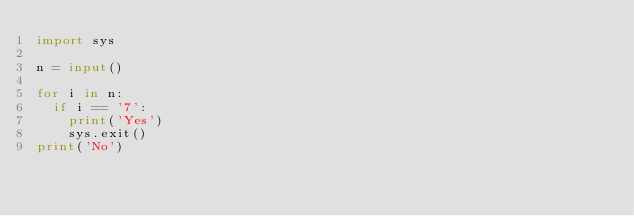<code> <loc_0><loc_0><loc_500><loc_500><_Python_>import sys

n = input()

for i in n:
  if i == '7':
    print('Yes')
    sys.exit()
print('No')

</code> 